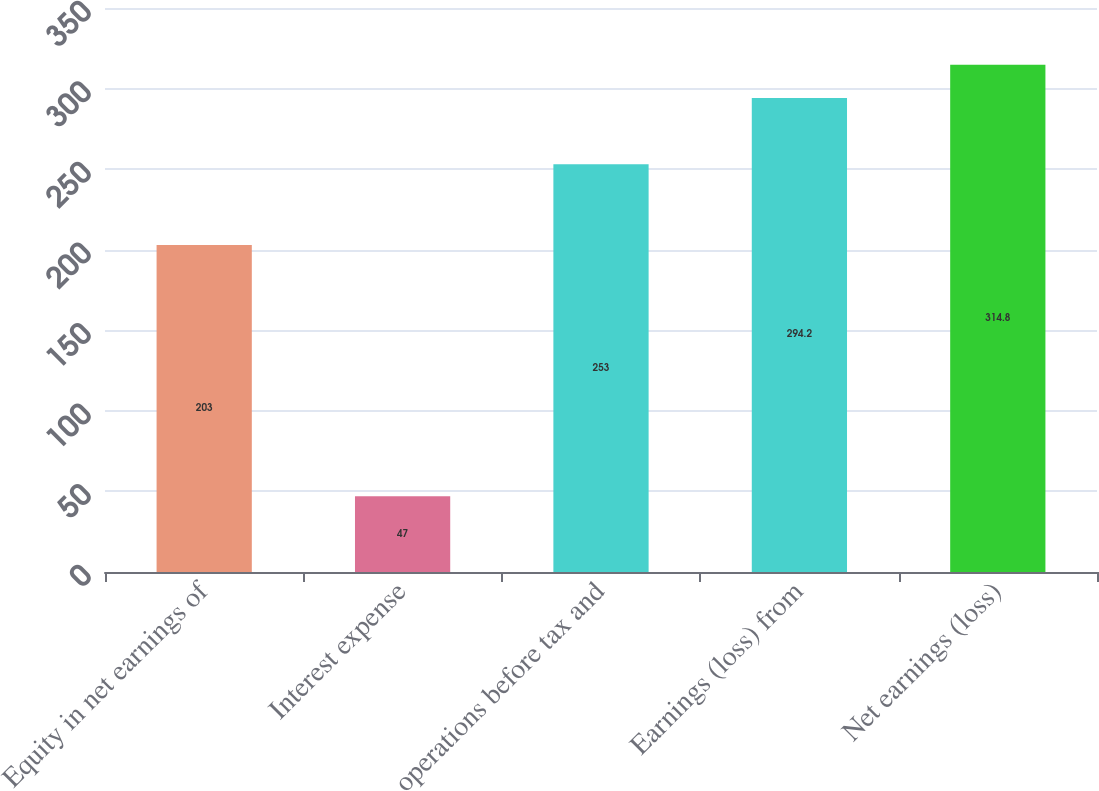Convert chart. <chart><loc_0><loc_0><loc_500><loc_500><bar_chart><fcel>Equity in net earnings of<fcel>Interest expense<fcel>operations before tax and<fcel>Earnings (loss) from<fcel>Net earnings (loss)<nl><fcel>203<fcel>47<fcel>253<fcel>294.2<fcel>314.8<nl></chart> 